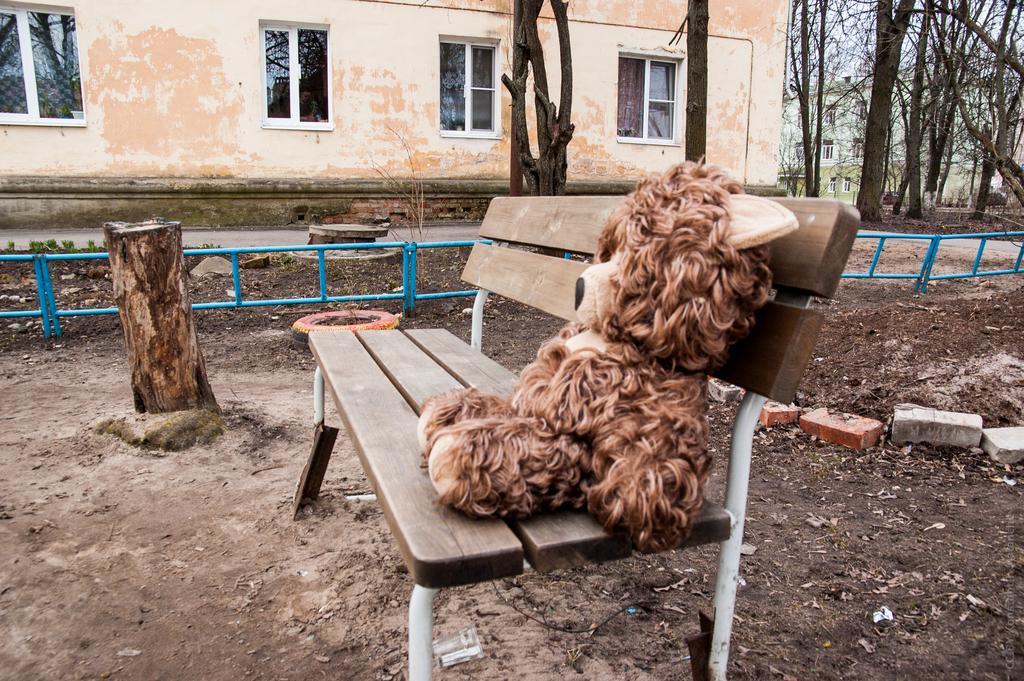Could you give a brief overview of what you see in this image? In this image I can see a bench in the front and on it I can see a brown colour soft toy. On the right side of the image I can see few bricks on the ground and on the left side I can see a tree trunk. In the background I can see the blue colour iron poles, number of trees, few buildings, number of windows and the sky. 